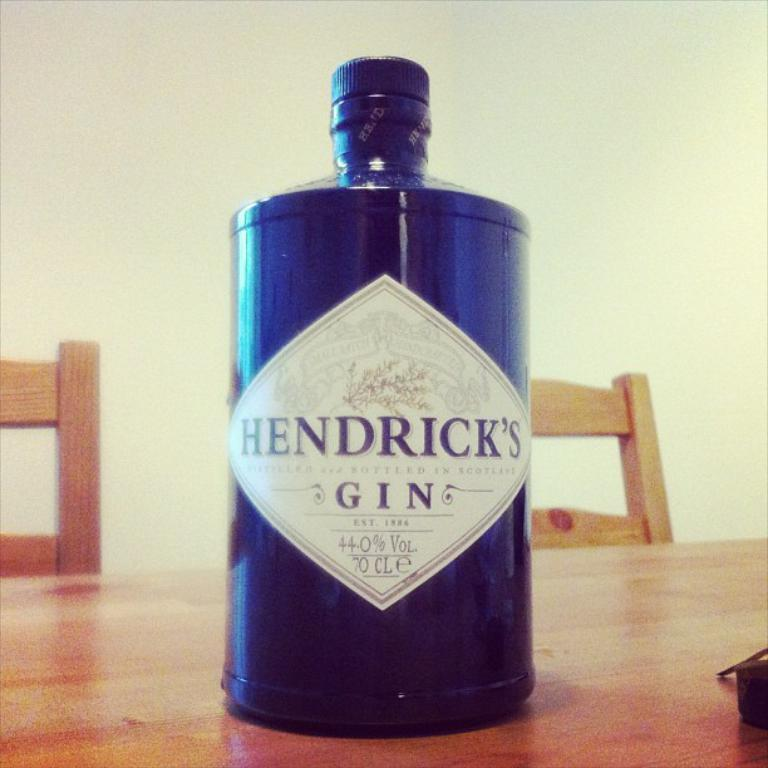Provide a one-sentence caption for the provided image. A Hendrick's Gin bottle sitting on a table. 